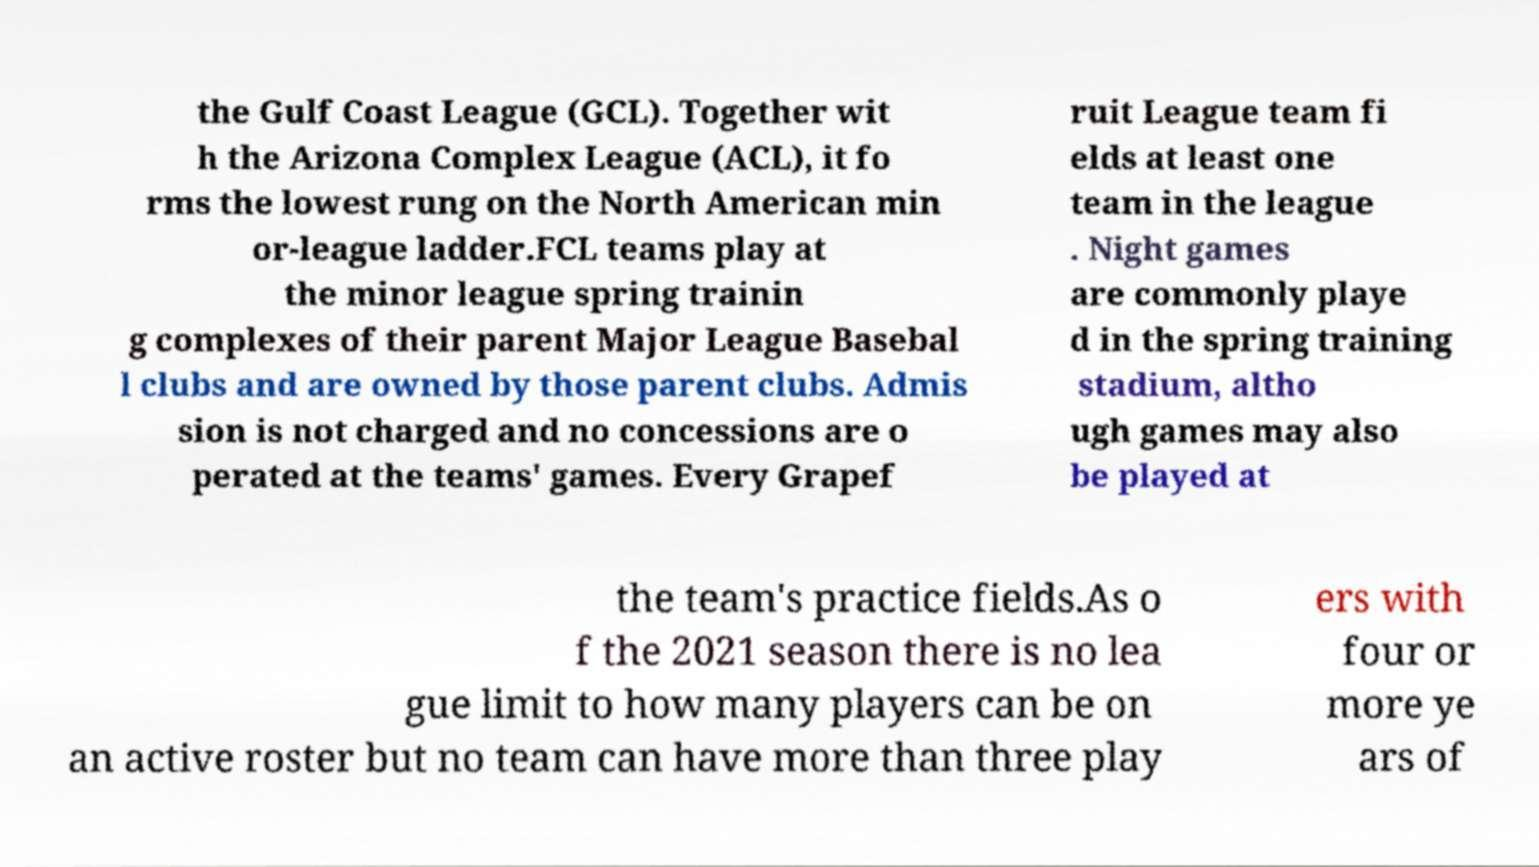Can you accurately transcribe the text from the provided image for me? the Gulf Coast League (GCL). Together wit h the Arizona Complex League (ACL), it fo rms the lowest rung on the North American min or-league ladder.FCL teams play at the minor league spring trainin g complexes of their parent Major League Basebal l clubs and are owned by those parent clubs. Admis sion is not charged and no concessions are o perated at the teams' games. Every Grapef ruit League team fi elds at least one team in the league . Night games are commonly playe d in the spring training stadium, altho ugh games may also be played at the team's practice fields.As o f the 2021 season there is no lea gue limit to how many players can be on an active roster but no team can have more than three play ers with four or more ye ars of 